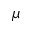<formula> <loc_0><loc_0><loc_500><loc_500>\mu</formula> 